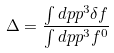Convert formula to latex. <formula><loc_0><loc_0><loc_500><loc_500>\Delta = \frac { \int d p p ^ { 3 } \delta f } { \int d p p ^ { 3 } f ^ { 0 } }</formula> 